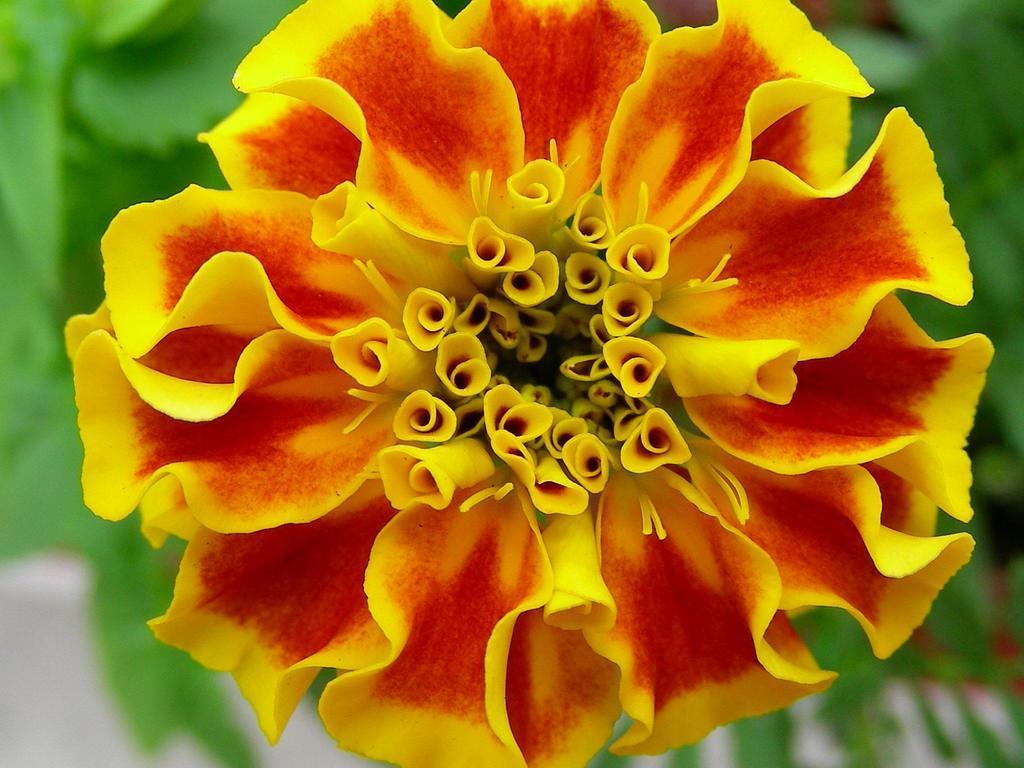How would you summarize this image in a sentence or two? In this picture there is a red and yellow color flower. Behind there is a green color blur background. 